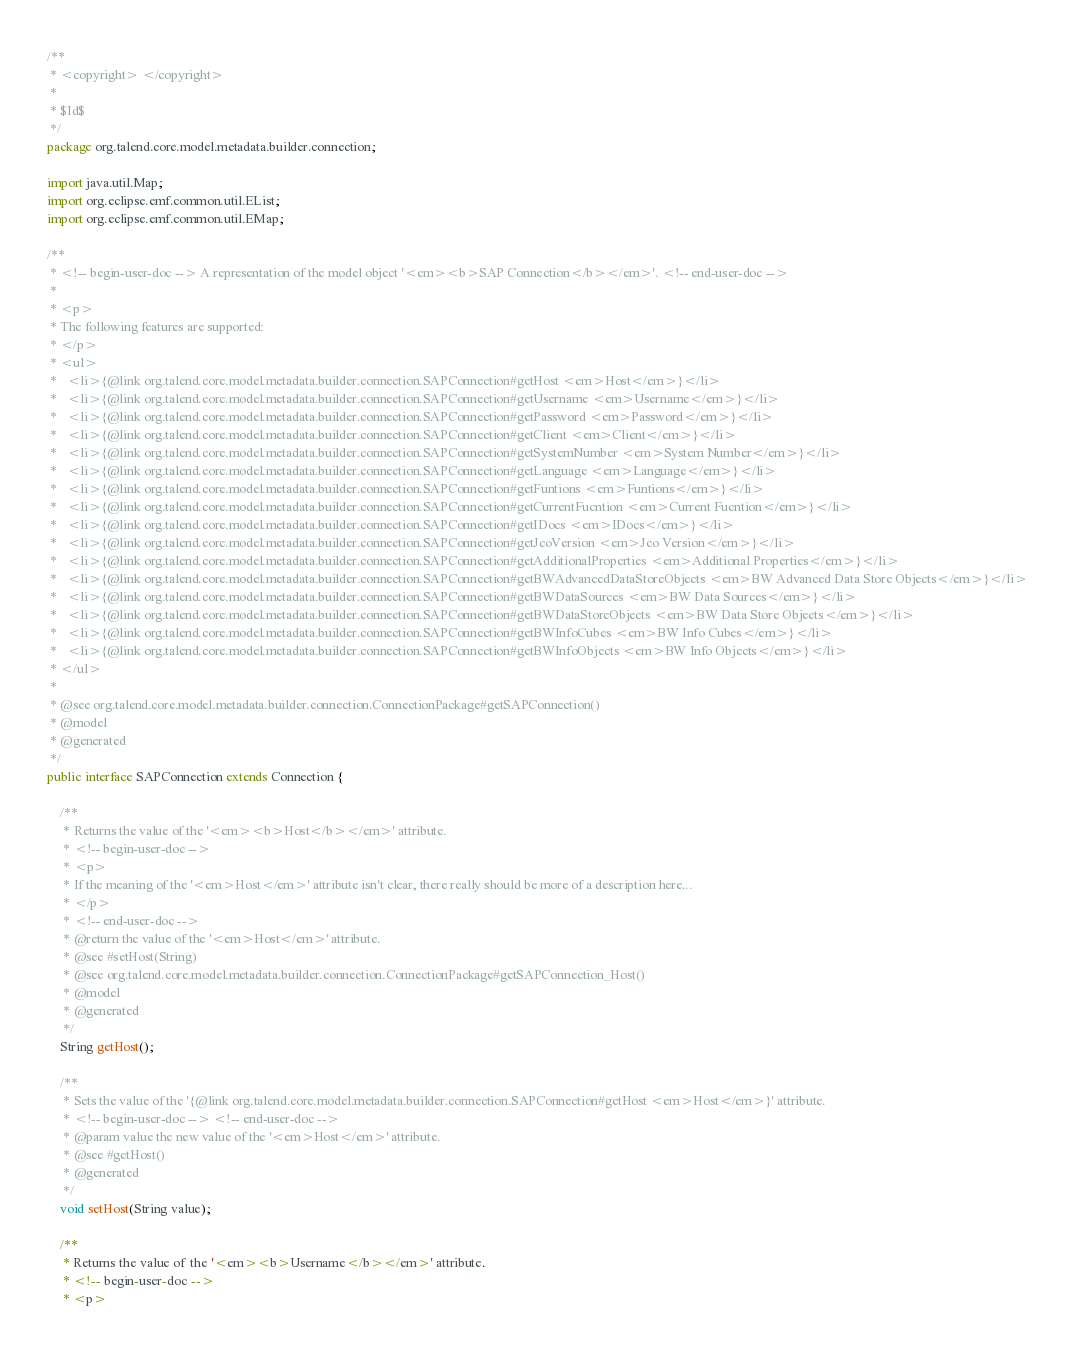Convert code to text. <code><loc_0><loc_0><loc_500><loc_500><_Java_>/**
 * <copyright> </copyright>
 * 
 * $Id$
 */
package org.talend.core.model.metadata.builder.connection;

import java.util.Map;
import org.eclipse.emf.common.util.EList;
import org.eclipse.emf.common.util.EMap;

/**
 * <!-- begin-user-doc --> A representation of the model object '<em><b>SAP Connection</b></em>'. <!-- end-user-doc -->
 *
 * <p>
 * The following features are supported:
 * </p>
 * <ul>
 *   <li>{@link org.talend.core.model.metadata.builder.connection.SAPConnection#getHost <em>Host</em>}</li>
 *   <li>{@link org.talend.core.model.metadata.builder.connection.SAPConnection#getUsername <em>Username</em>}</li>
 *   <li>{@link org.talend.core.model.metadata.builder.connection.SAPConnection#getPassword <em>Password</em>}</li>
 *   <li>{@link org.talend.core.model.metadata.builder.connection.SAPConnection#getClient <em>Client</em>}</li>
 *   <li>{@link org.talend.core.model.metadata.builder.connection.SAPConnection#getSystemNumber <em>System Number</em>}</li>
 *   <li>{@link org.talend.core.model.metadata.builder.connection.SAPConnection#getLanguage <em>Language</em>}</li>
 *   <li>{@link org.talend.core.model.metadata.builder.connection.SAPConnection#getFuntions <em>Funtions</em>}</li>
 *   <li>{@link org.talend.core.model.metadata.builder.connection.SAPConnection#getCurrentFucntion <em>Current Fucntion</em>}</li>
 *   <li>{@link org.talend.core.model.metadata.builder.connection.SAPConnection#getIDocs <em>IDocs</em>}</li>
 *   <li>{@link org.talend.core.model.metadata.builder.connection.SAPConnection#getJcoVersion <em>Jco Version</em>}</li>
 *   <li>{@link org.talend.core.model.metadata.builder.connection.SAPConnection#getAdditionalProperties <em>Additional Properties</em>}</li>
 *   <li>{@link org.talend.core.model.metadata.builder.connection.SAPConnection#getBWAdvancedDataStoreObjects <em>BW Advanced Data Store Objects</em>}</li>
 *   <li>{@link org.talend.core.model.metadata.builder.connection.SAPConnection#getBWDataSources <em>BW Data Sources</em>}</li>
 *   <li>{@link org.talend.core.model.metadata.builder.connection.SAPConnection#getBWDataStoreObjects <em>BW Data Store Objects</em>}</li>
 *   <li>{@link org.talend.core.model.metadata.builder.connection.SAPConnection#getBWInfoCubes <em>BW Info Cubes</em>}</li>
 *   <li>{@link org.talend.core.model.metadata.builder.connection.SAPConnection#getBWInfoObjects <em>BW Info Objects</em>}</li>
 * </ul>
 *
 * @see org.talend.core.model.metadata.builder.connection.ConnectionPackage#getSAPConnection()
 * @model
 * @generated
 */
public interface SAPConnection extends Connection {

    /**
     * Returns the value of the '<em><b>Host</b></em>' attribute.
     * <!-- begin-user-doc -->
     * <p>
     * If the meaning of the '<em>Host</em>' attribute isn't clear, there really should be more of a description here...
     * </p>
     * <!-- end-user-doc -->
     * @return the value of the '<em>Host</em>' attribute.
     * @see #setHost(String)
     * @see org.talend.core.model.metadata.builder.connection.ConnectionPackage#getSAPConnection_Host()
     * @model
     * @generated
     */
    String getHost();

    /**
     * Sets the value of the '{@link org.talend.core.model.metadata.builder.connection.SAPConnection#getHost <em>Host</em>}' attribute.
     * <!-- begin-user-doc --> <!-- end-user-doc -->
     * @param value the new value of the '<em>Host</em>' attribute.
     * @see #getHost()
     * @generated
     */
    void setHost(String value);

    /**
     * Returns the value of the '<em><b>Username</b></em>' attribute.
     * <!-- begin-user-doc -->
     * <p></code> 